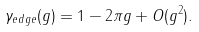<formula> <loc_0><loc_0><loc_500><loc_500>\gamma _ { e d g e } ( g ) = 1 - 2 \pi g + O ( g ^ { 2 } ) .</formula> 